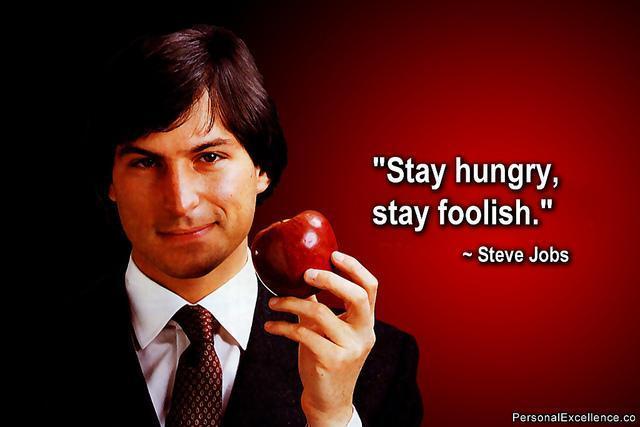How many blue frosted donuts can you count?
Give a very brief answer. 0. 